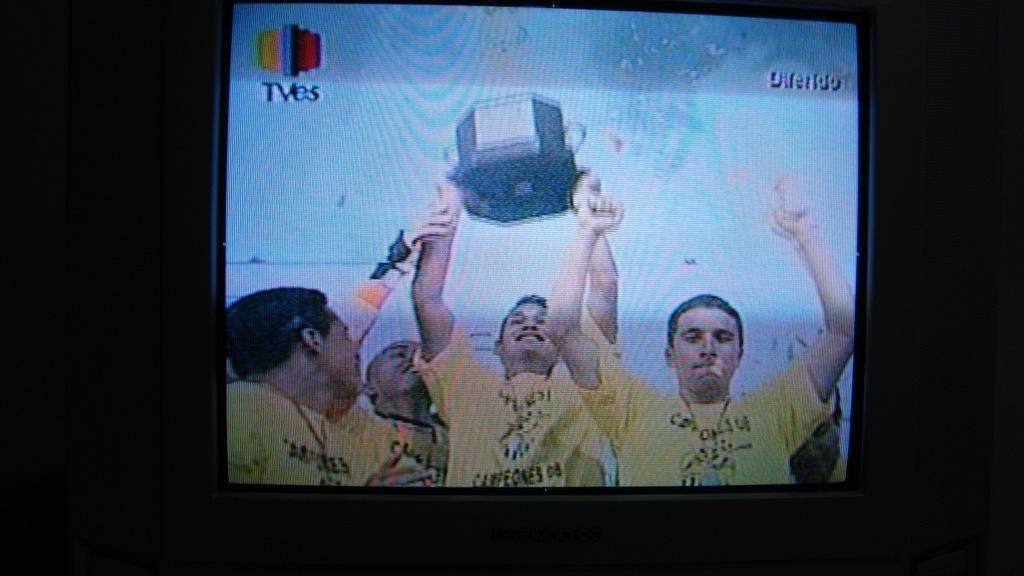What is the main object in the image? There is a television screen in the image. What is happening on the television screen? People lifting a trophy are visible on the television screen. What can be observed about the lighting in the image? The area to the left and right of the television screen is dark. What decision is being made by the people reading a form in the image? There is no mention of people reading a form in the image; the main focus is on the television screen and the people lifting a trophy. 